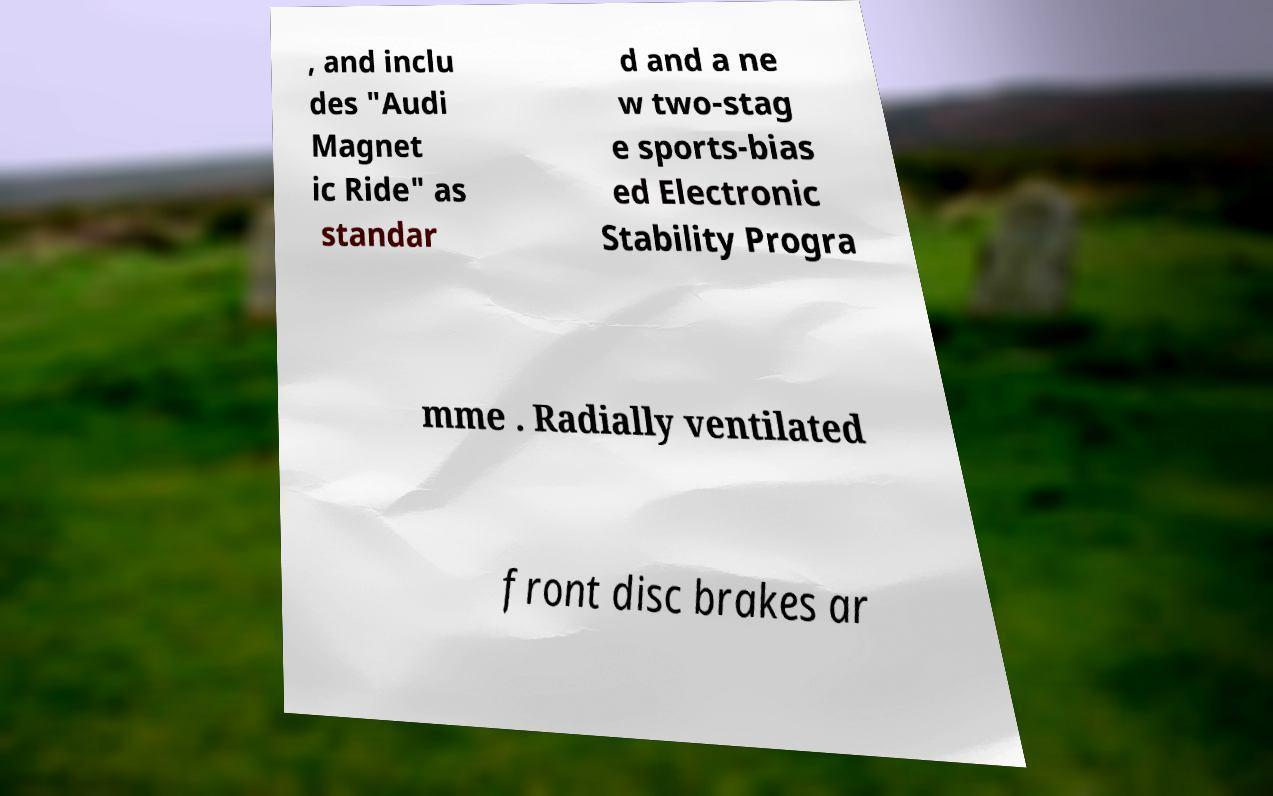What messages or text are displayed in this image? I need them in a readable, typed format. , and inclu des "Audi Magnet ic Ride" as standar d and a ne w two-stag e sports-bias ed Electronic Stability Progra mme . Radially ventilated front disc brakes ar 